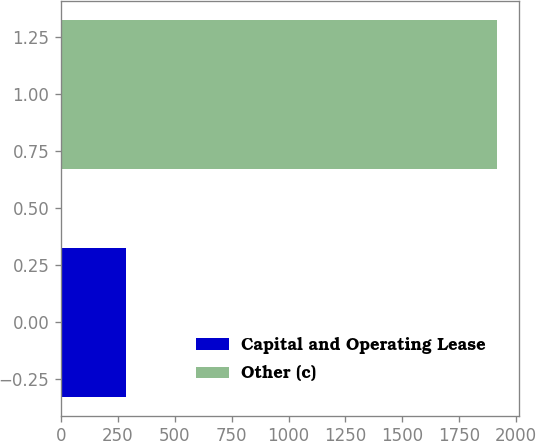Convert chart. <chart><loc_0><loc_0><loc_500><loc_500><bar_chart><fcel>Capital and Operating Lease<fcel>Other (c)<nl><fcel>286<fcel>1917<nl></chart> 